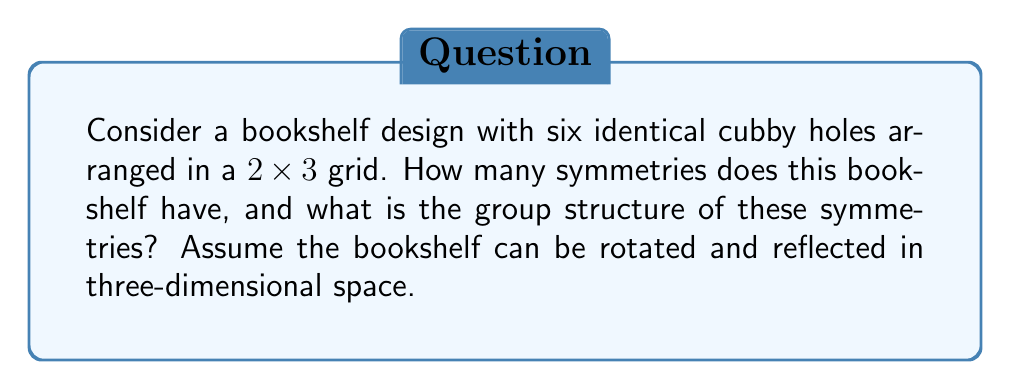Teach me how to tackle this problem. To analyze the symmetries of this bookshelf design, we'll use group theory concepts:

1) First, let's identify the possible symmetry operations:
   - Rotations: 180° rotation around the x-axis, y-axis, and z-axis
   - Reflections: across the xy-plane, xz-plane, and yz-plane
   - Identity: leaving the bookshelf unchanged

2) Let's count these symmetries:
   - 1 identity operation
   - 3 rotations (one for each axis)
   - 3 reflections (one for each plane)

   Total: 1 + 3 + 3 = 7 symmetries

3) Now, let's determine the group structure:
   - All these operations, when combined, produce another operation in the set
   - The identity element exists
   - Each operation has an inverse in the set
   - The operations are associative

4) This group of symmetries is isomorphic to the dihedral group $D_3$, which is the symmetry group of an equilateral triangle. Here's why:
   - $D_3$ has 6 elements: 3 rotations and 3 reflections, plus the identity
   - Our bookshelf symmetry group has 7 elements, but the 180° rotation around the z-axis (front-to-back) is equivalent to the identity for this 2x3 grid

5) The group structure of $D_3$ is:
   $$D_3 = \langle r, s \mid r^3 = s^2 = 1, srs = r^{-1} \rangle$$
   Where $r$ represents a 120° rotation and $s$ represents a reflection.

In our bookshelf case:
- $r$ could represent the cycle of x-axis rotation → y-axis rotation → identity
- $s$ could represent any of the reflections

This group is non-abelian, meaning the order of operations matters (e.g., rotating then reflecting is not always the same as reflecting then rotating).
Answer: The bookshelf has 7 symmetries, and the symmetry group is isomorphic to the dihedral group $D_3$. 